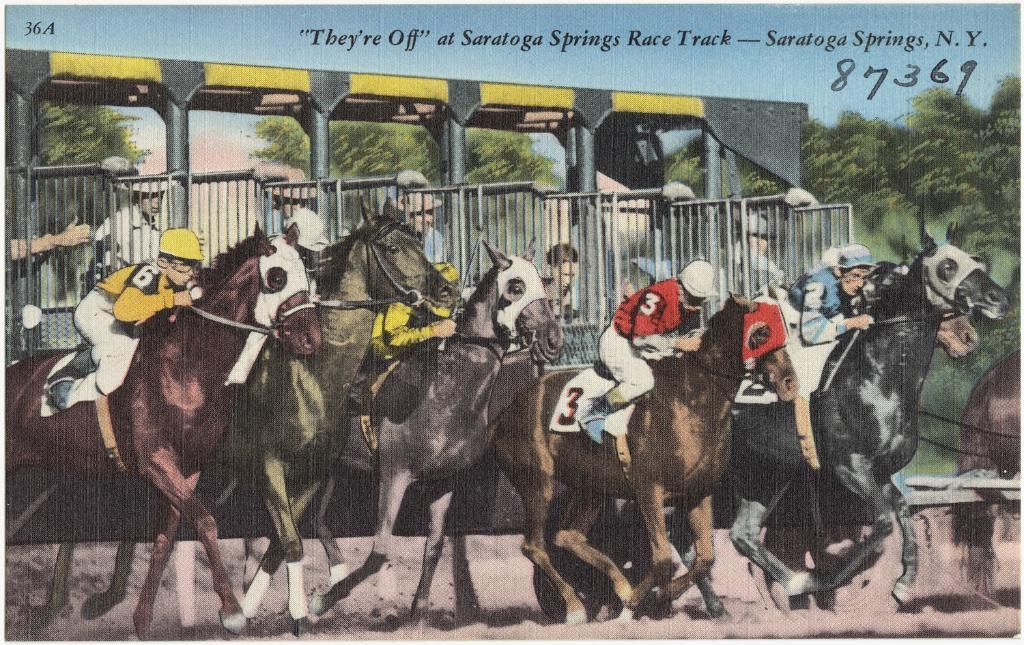What is present in the image that contains both images and text? There is a poster in the image that contains images and text. What type of liquid can be seen flowing from the images on the poster? There is no liquid present in the image, as it only contains a poster with images and text. 